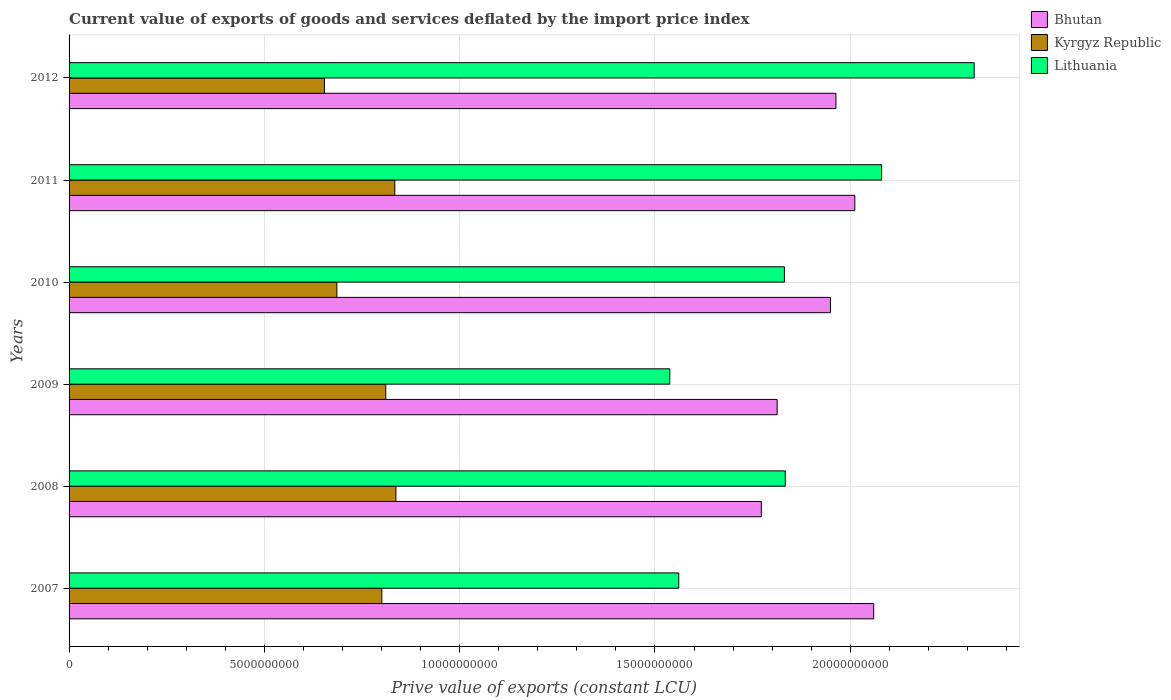Are the number of bars per tick equal to the number of legend labels?
Your answer should be very brief. Yes. Are the number of bars on each tick of the Y-axis equal?
Your answer should be very brief. Yes. How many bars are there on the 5th tick from the top?
Make the answer very short. 3. In how many cases, is the number of bars for a given year not equal to the number of legend labels?
Offer a terse response. 0. What is the prive value of exports in Lithuania in 2010?
Keep it short and to the point. 1.83e+1. Across all years, what is the maximum prive value of exports in Kyrgyz Republic?
Ensure brevity in your answer.  8.37e+09. Across all years, what is the minimum prive value of exports in Bhutan?
Your response must be concise. 1.77e+1. What is the total prive value of exports in Kyrgyz Republic in the graph?
Your answer should be compact. 4.62e+1. What is the difference between the prive value of exports in Bhutan in 2008 and that in 2011?
Your answer should be very brief. -2.39e+09. What is the difference between the prive value of exports in Bhutan in 2010 and the prive value of exports in Kyrgyz Republic in 2007?
Make the answer very short. 1.15e+1. What is the average prive value of exports in Kyrgyz Republic per year?
Offer a very short reply. 7.70e+09. In the year 2008, what is the difference between the prive value of exports in Bhutan and prive value of exports in Lithuania?
Ensure brevity in your answer.  -6.13e+08. What is the ratio of the prive value of exports in Lithuania in 2008 to that in 2011?
Your answer should be compact. 0.88. Is the prive value of exports in Kyrgyz Republic in 2008 less than that in 2009?
Ensure brevity in your answer.  No. What is the difference between the highest and the second highest prive value of exports in Kyrgyz Republic?
Offer a very short reply. 2.85e+07. What is the difference between the highest and the lowest prive value of exports in Kyrgyz Republic?
Provide a short and direct response. 1.83e+09. In how many years, is the prive value of exports in Lithuania greater than the average prive value of exports in Lithuania taken over all years?
Make the answer very short. 2. What does the 1st bar from the top in 2010 represents?
Keep it short and to the point. Lithuania. What does the 3rd bar from the bottom in 2009 represents?
Provide a short and direct response. Lithuania. Is it the case that in every year, the sum of the prive value of exports in Lithuania and prive value of exports in Kyrgyz Republic is greater than the prive value of exports in Bhutan?
Provide a succinct answer. Yes. Are all the bars in the graph horizontal?
Make the answer very short. Yes. How many years are there in the graph?
Make the answer very short. 6. What is the difference between two consecutive major ticks on the X-axis?
Provide a short and direct response. 5.00e+09. Does the graph contain grids?
Keep it short and to the point. Yes. How many legend labels are there?
Make the answer very short. 3. What is the title of the graph?
Your response must be concise. Current value of exports of goods and services deflated by the import price index. What is the label or title of the X-axis?
Offer a very short reply. Prive value of exports (constant LCU). What is the label or title of the Y-axis?
Offer a very short reply. Years. What is the Prive value of exports (constant LCU) in Bhutan in 2007?
Give a very brief answer. 2.06e+1. What is the Prive value of exports (constant LCU) of Kyrgyz Republic in 2007?
Make the answer very short. 8.01e+09. What is the Prive value of exports (constant LCU) in Lithuania in 2007?
Your answer should be compact. 1.56e+1. What is the Prive value of exports (constant LCU) in Bhutan in 2008?
Your answer should be very brief. 1.77e+1. What is the Prive value of exports (constant LCU) in Kyrgyz Republic in 2008?
Offer a terse response. 8.37e+09. What is the Prive value of exports (constant LCU) of Lithuania in 2008?
Provide a short and direct response. 1.83e+1. What is the Prive value of exports (constant LCU) of Bhutan in 2009?
Your answer should be compact. 1.81e+1. What is the Prive value of exports (constant LCU) in Kyrgyz Republic in 2009?
Your answer should be compact. 8.11e+09. What is the Prive value of exports (constant LCU) of Lithuania in 2009?
Make the answer very short. 1.54e+1. What is the Prive value of exports (constant LCU) in Bhutan in 2010?
Your answer should be very brief. 1.95e+1. What is the Prive value of exports (constant LCU) in Kyrgyz Republic in 2010?
Ensure brevity in your answer.  6.86e+09. What is the Prive value of exports (constant LCU) of Lithuania in 2010?
Your answer should be compact. 1.83e+1. What is the Prive value of exports (constant LCU) in Bhutan in 2011?
Your response must be concise. 2.01e+1. What is the Prive value of exports (constant LCU) in Kyrgyz Republic in 2011?
Offer a very short reply. 8.34e+09. What is the Prive value of exports (constant LCU) of Lithuania in 2011?
Make the answer very short. 2.08e+1. What is the Prive value of exports (constant LCU) in Bhutan in 2012?
Give a very brief answer. 1.96e+1. What is the Prive value of exports (constant LCU) of Kyrgyz Republic in 2012?
Ensure brevity in your answer.  6.54e+09. What is the Prive value of exports (constant LCU) of Lithuania in 2012?
Make the answer very short. 2.32e+1. Across all years, what is the maximum Prive value of exports (constant LCU) in Bhutan?
Provide a succinct answer. 2.06e+1. Across all years, what is the maximum Prive value of exports (constant LCU) of Kyrgyz Republic?
Provide a short and direct response. 8.37e+09. Across all years, what is the maximum Prive value of exports (constant LCU) in Lithuania?
Provide a succinct answer. 2.32e+1. Across all years, what is the minimum Prive value of exports (constant LCU) of Bhutan?
Provide a succinct answer. 1.77e+1. Across all years, what is the minimum Prive value of exports (constant LCU) in Kyrgyz Republic?
Your answer should be very brief. 6.54e+09. Across all years, what is the minimum Prive value of exports (constant LCU) in Lithuania?
Your response must be concise. 1.54e+1. What is the total Prive value of exports (constant LCU) in Bhutan in the graph?
Your answer should be very brief. 1.16e+11. What is the total Prive value of exports (constant LCU) in Kyrgyz Republic in the graph?
Offer a terse response. 4.62e+1. What is the total Prive value of exports (constant LCU) in Lithuania in the graph?
Provide a short and direct response. 1.12e+11. What is the difference between the Prive value of exports (constant LCU) in Bhutan in 2007 and that in 2008?
Provide a short and direct response. 2.88e+09. What is the difference between the Prive value of exports (constant LCU) of Kyrgyz Republic in 2007 and that in 2008?
Your answer should be compact. -3.60e+08. What is the difference between the Prive value of exports (constant LCU) of Lithuania in 2007 and that in 2008?
Keep it short and to the point. -2.73e+09. What is the difference between the Prive value of exports (constant LCU) of Bhutan in 2007 and that in 2009?
Offer a very short reply. 2.47e+09. What is the difference between the Prive value of exports (constant LCU) in Kyrgyz Republic in 2007 and that in 2009?
Your answer should be compact. -1.00e+08. What is the difference between the Prive value of exports (constant LCU) of Lithuania in 2007 and that in 2009?
Keep it short and to the point. 2.30e+08. What is the difference between the Prive value of exports (constant LCU) in Bhutan in 2007 and that in 2010?
Provide a succinct answer. 1.11e+09. What is the difference between the Prive value of exports (constant LCU) of Kyrgyz Republic in 2007 and that in 2010?
Offer a very short reply. 1.15e+09. What is the difference between the Prive value of exports (constant LCU) of Lithuania in 2007 and that in 2010?
Provide a succinct answer. -2.71e+09. What is the difference between the Prive value of exports (constant LCU) of Bhutan in 2007 and that in 2011?
Ensure brevity in your answer.  4.83e+08. What is the difference between the Prive value of exports (constant LCU) of Kyrgyz Republic in 2007 and that in 2011?
Your answer should be compact. -3.32e+08. What is the difference between the Prive value of exports (constant LCU) in Lithuania in 2007 and that in 2011?
Offer a very short reply. -5.19e+09. What is the difference between the Prive value of exports (constant LCU) in Bhutan in 2007 and that in 2012?
Offer a terse response. 9.67e+08. What is the difference between the Prive value of exports (constant LCU) in Kyrgyz Republic in 2007 and that in 2012?
Give a very brief answer. 1.47e+09. What is the difference between the Prive value of exports (constant LCU) of Lithuania in 2007 and that in 2012?
Make the answer very short. -7.56e+09. What is the difference between the Prive value of exports (constant LCU) in Bhutan in 2008 and that in 2009?
Offer a very short reply. -4.05e+08. What is the difference between the Prive value of exports (constant LCU) in Kyrgyz Republic in 2008 and that in 2009?
Provide a succinct answer. 2.60e+08. What is the difference between the Prive value of exports (constant LCU) in Lithuania in 2008 and that in 2009?
Keep it short and to the point. 2.96e+09. What is the difference between the Prive value of exports (constant LCU) of Bhutan in 2008 and that in 2010?
Your answer should be compact. -1.77e+09. What is the difference between the Prive value of exports (constant LCU) in Kyrgyz Republic in 2008 and that in 2010?
Keep it short and to the point. 1.51e+09. What is the difference between the Prive value of exports (constant LCU) in Lithuania in 2008 and that in 2010?
Provide a succinct answer. 2.17e+07. What is the difference between the Prive value of exports (constant LCU) in Bhutan in 2008 and that in 2011?
Provide a short and direct response. -2.39e+09. What is the difference between the Prive value of exports (constant LCU) in Kyrgyz Republic in 2008 and that in 2011?
Provide a succinct answer. 2.85e+07. What is the difference between the Prive value of exports (constant LCU) of Lithuania in 2008 and that in 2011?
Offer a very short reply. -2.47e+09. What is the difference between the Prive value of exports (constant LCU) in Bhutan in 2008 and that in 2012?
Your answer should be compact. -1.91e+09. What is the difference between the Prive value of exports (constant LCU) in Kyrgyz Republic in 2008 and that in 2012?
Offer a terse response. 1.83e+09. What is the difference between the Prive value of exports (constant LCU) in Lithuania in 2008 and that in 2012?
Your answer should be very brief. -4.84e+09. What is the difference between the Prive value of exports (constant LCU) of Bhutan in 2009 and that in 2010?
Offer a terse response. -1.36e+09. What is the difference between the Prive value of exports (constant LCU) in Kyrgyz Republic in 2009 and that in 2010?
Offer a very short reply. 1.25e+09. What is the difference between the Prive value of exports (constant LCU) of Lithuania in 2009 and that in 2010?
Your answer should be very brief. -2.94e+09. What is the difference between the Prive value of exports (constant LCU) in Bhutan in 2009 and that in 2011?
Provide a short and direct response. -1.99e+09. What is the difference between the Prive value of exports (constant LCU) in Kyrgyz Republic in 2009 and that in 2011?
Give a very brief answer. -2.32e+08. What is the difference between the Prive value of exports (constant LCU) of Lithuania in 2009 and that in 2011?
Your answer should be very brief. -5.42e+09. What is the difference between the Prive value of exports (constant LCU) in Bhutan in 2009 and that in 2012?
Provide a short and direct response. -1.50e+09. What is the difference between the Prive value of exports (constant LCU) of Kyrgyz Republic in 2009 and that in 2012?
Offer a terse response. 1.57e+09. What is the difference between the Prive value of exports (constant LCU) of Lithuania in 2009 and that in 2012?
Provide a succinct answer. -7.79e+09. What is the difference between the Prive value of exports (constant LCU) in Bhutan in 2010 and that in 2011?
Keep it short and to the point. -6.25e+08. What is the difference between the Prive value of exports (constant LCU) in Kyrgyz Republic in 2010 and that in 2011?
Offer a very short reply. -1.48e+09. What is the difference between the Prive value of exports (constant LCU) in Lithuania in 2010 and that in 2011?
Give a very brief answer. -2.49e+09. What is the difference between the Prive value of exports (constant LCU) in Bhutan in 2010 and that in 2012?
Give a very brief answer. -1.41e+08. What is the difference between the Prive value of exports (constant LCU) of Kyrgyz Republic in 2010 and that in 2012?
Ensure brevity in your answer.  3.18e+08. What is the difference between the Prive value of exports (constant LCU) in Lithuania in 2010 and that in 2012?
Ensure brevity in your answer.  -4.86e+09. What is the difference between the Prive value of exports (constant LCU) of Bhutan in 2011 and that in 2012?
Provide a succinct answer. 4.83e+08. What is the difference between the Prive value of exports (constant LCU) in Kyrgyz Republic in 2011 and that in 2012?
Ensure brevity in your answer.  1.80e+09. What is the difference between the Prive value of exports (constant LCU) in Lithuania in 2011 and that in 2012?
Provide a short and direct response. -2.37e+09. What is the difference between the Prive value of exports (constant LCU) in Bhutan in 2007 and the Prive value of exports (constant LCU) in Kyrgyz Republic in 2008?
Your answer should be compact. 1.22e+1. What is the difference between the Prive value of exports (constant LCU) in Bhutan in 2007 and the Prive value of exports (constant LCU) in Lithuania in 2008?
Offer a very short reply. 2.26e+09. What is the difference between the Prive value of exports (constant LCU) in Kyrgyz Republic in 2007 and the Prive value of exports (constant LCU) in Lithuania in 2008?
Provide a short and direct response. -1.03e+1. What is the difference between the Prive value of exports (constant LCU) in Bhutan in 2007 and the Prive value of exports (constant LCU) in Kyrgyz Republic in 2009?
Your answer should be very brief. 1.25e+1. What is the difference between the Prive value of exports (constant LCU) in Bhutan in 2007 and the Prive value of exports (constant LCU) in Lithuania in 2009?
Your response must be concise. 5.22e+09. What is the difference between the Prive value of exports (constant LCU) in Kyrgyz Republic in 2007 and the Prive value of exports (constant LCU) in Lithuania in 2009?
Provide a short and direct response. -7.37e+09. What is the difference between the Prive value of exports (constant LCU) of Bhutan in 2007 and the Prive value of exports (constant LCU) of Kyrgyz Republic in 2010?
Your response must be concise. 1.37e+1. What is the difference between the Prive value of exports (constant LCU) in Bhutan in 2007 and the Prive value of exports (constant LCU) in Lithuania in 2010?
Offer a terse response. 2.29e+09. What is the difference between the Prive value of exports (constant LCU) of Kyrgyz Republic in 2007 and the Prive value of exports (constant LCU) of Lithuania in 2010?
Offer a very short reply. -1.03e+1. What is the difference between the Prive value of exports (constant LCU) in Bhutan in 2007 and the Prive value of exports (constant LCU) in Kyrgyz Republic in 2011?
Your answer should be compact. 1.23e+1. What is the difference between the Prive value of exports (constant LCU) of Bhutan in 2007 and the Prive value of exports (constant LCU) of Lithuania in 2011?
Provide a short and direct response. -2.03e+08. What is the difference between the Prive value of exports (constant LCU) in Kyrgyz Republic in 2007 and the Prive value of exports (constant LCU) in Lithuania in 2011?
Offer a very short reply. -1.28e+1. What is the difference between the Prive value of exports (constant LCU) of Bhutan in 2007 and the Prive value of exports (constant LCU) of Kyrgyz Republic in 2012?
Your answer should be compact. 1.41e+1. What is the difference between the Prive value of exports (constant LCU) of Bhutan in 2007 and the Prive value of exports (constant LCU) of Lithuania in 2012?
Make the answer very short. -2.57e+09. What is the difference between the Prive value of exports (constant LCU) of Kyrgyz Republic in 2007 and the Prive value of exports (constant LCU) of Lithuania in 2012?
Your answer should be compact. -1.52e+1. What is the difference between the Prive value of exports (constant LCU) of Bhutan in 2008 and the Prive value of exports (constant LCU) of Kyrgyz Republic in 2009?
Provide a succinct answer. 9.62e+09. What is the difference between the Prive value of exports (constant LCU) in Bhutan in 2008 and the Prive value of exports (constant LCU) in Lithuania in 2009?
Make the answer very short. 2.34e+09. What is the difference between the Prive value of exports (constant LCU) of Kyrgyz Republic in 2008 and the Prive value of exports (constant LCU) of Lithuania in 2009?
Make the answer very short. -7.01e+09. What is the difference between the Prive value of exports (constant LCU) in Bhutan in 2008 and the Prive value of exports (constant LCU) in Kyrgyz Republic in 2010?
Your answer should be very brief. 1.09e+1. What is the difference between the Prive value of exports (constant LCU) of Bhutan in 2008 and the Prive value of exports (constant LCU) of Lithuania in 2010?
Keep it short and to the point. -5.91e+08. What is the difference between the Prive value of exports (constant LCU) of Kyrgyz Republic in 2008 and the Prive value of exports (constant LCU) of Lithuania in 2010?
Give a very brief answer. -9.95e+09. What is the difference between the Prive value of exports (constant LCU) of Bhutan in 2008 and the Prive value of exports (constant LCU) of Kyrgyz Republic in 2011?
Keep it short and to the point. 9.38e+09. What is the difference between the Prive value of exports (constant LCU) in Bhutan in 2008 and the Prive value of exports (constant LCU) in Lithuania in 2011?
Offer a terse response. -3.08e+09. What is the difference between the Prive value of exports (constant LCU) of Kyrgyz Republic in 2008 and the Prive value of exports (constant LCU) of Lithuania in 2011?
Provide a short and direct response. -1.24e+1. What is the difference between the Prive value of exports (constant LCU) of Bhutan in 2008 and the Prive value of exports (constant LCU) of Kyrgyz Republic in 2012?
Provide a succinct answer. 1.12e+1. What is the difference between the Prive value of exports (constant LCU) of Bhutan in 2008 and the Prive value of exports (constant LCU) of Lithuania in 2012?
Ensure brevity in your answer.  -5.45e+09. What is the difference between the Prive value of exports (constant LCU) of Kyrgyz Republic in 2008 and the Prive value of exports (constant LCU) of Lithuania in 2012?
Your answer should be compact. -1.48e+1. What is the difference between the Prive value of exports (constant LCU) in Bhutan in 2009 and the Prive value of exports (constant LCU) in Kyrgyz Republic in 2010?
Provide a succinct answer. 1.13e+1. What is the difference between the Prive value of exports (constant LCU) in Bhutan in 2009 and the Prive value of exports (constant LCU) in Lithuania in 2010?
Provide a short and direct response. -1.86e+08. What is the difference between the Prive value of exports (constant LCU) of Kyrgyz Republic in 2009 and the Prive value of exports (constant LCU) of Lithuania in 2010?
Your answer should be very brief. -1.02e+1. What is the difference between the Prive value of exports (constant LCU) in Bhutan in 2009 and the Prive value of exports (constant LCU) in Kyrgyz Republic in 2011?
Provide a succinct answer. 9.79e+09. What is the difference between the Prive value of exports (constant LCU) in Bhutan in 2009 and the Prive value of exports (constant LCU) in Lithuania in 2011?
Offer a very short reply. -2.67e+09. What is the difference between the Prive value of exports (constant LCU) in Kyrgyz Republic in 2009 and the Prive value of exports (constant LCU) in Lithuania in 2011?
Your answer should be compact. -1.27e+1. What is the difference between the Prive value of exports (constant LCU) in Bhutan in 2009 and the Prive value of exports (constant LCU) in Kyrgyz Republic in 2012?
Offer a terse response. 1.16e+1. What is the difference between the Prive value of exports (constant LCU) in Bhutan in 2009 and the Prive value of exports (constant LCU) in Lithuania in 2012?
Give a very brief answer. -5.04e+09. What is the difference between the Prive value of exports (constant LCU) of Kyrgyz Republic in 2009 and the Prive value of exports (constant LCU) of Lithuania in 2012?
Offer a very short reply. -1.51e+1. What is the difference between the Prive value of exports (constant LCU) of Bhutan in 2010 and the Prive value of exports (constant LCU) of Kyrgyz Republic in 2011?
Ensure brevity in your answer.  1.12e+1. What is the difference between the Prive value of exports (constant LCU) of Bhutan in 2010 and the Prive value of exports (constant LCU) of Lithuania in 2011?
Give a very brief answer. -1.31e+09. What is the difference between the Prive value of exports (constant LCU) of Kyrgyz Republic in 2010 and the Prive value of exports (constant LCU) of Lithuania in 2011?
Give a very brief answer. -1.39e+1. What is the difference between the Prive value of exports (constant LCU) in Bhutan in 2010 and the Prive value of exports (constant LCU) in Kyrgyz Republic in 2012?
Offer a very short reply. 1.30e+1. What is the difference between the Prive value of exports (constant LCU) in Bhutan in 2010 and the Prive value of exports (constant LCU) in Lithuania in 2012?
Offer a very short reply. -3.68e+09. What is the difference between the Prive value of exports (constant LCU) in Kyrgyz Republic in 2010 and the Prive value of exports (constant LCU) in Lithuania in 2012?
Give a very brief answer. -1.63e+1. What is the difference between the Prive value of exports (constant LCU) of Bhutan in 2011 and the Prive value of exports (constant LCU) of Kyrgyz Republic in 2012?
Provide a succinct answer. 1.36e+1. What is the difference between the Prive value of exports (constant LCU) in Bhutan in 2011 and the Prive value of exports (constant LCU) in Lithuania in 2012?
Make the answer very short. -3.06e+09. What is the difference between the Prive value of exports (constant LCU) of Kyrgyz Republic in 2011 and the Prive value of exports (constant LCU) of Lithuania in 2012?
Provide a short and direct response. -1.48e+1. What is the average Prive value of exports (constant LCU) in Bhutan per year?
Keep it short and to the point. 1.93e+1. What is the average Prive value of exports (constant LCU) in Kyrgyz Republic per year?
Provide a short and direct response. 7.70e+09. What is the average Prive value of exports (constant LCU) in Lithuania per year?
Offer a very short reply. 1.86e+1. In the year 2007, what is the difference between the Prive value of exports (constant LCU) of Bhutan and Prive value of exports (constant LCU) of Kyrgyz Republic?
Offer a terse response. 1.26e+1. In the year 2007, what is the difference between the Prive value of exports (constant LCU) in Bhutan and Prive value of exports (constant LCU) in Lithuania?
Give a very brief answer. 4.99e+09. In the year 2007, what is the difference between the Prive value of exports (constant LCU) of Kyrgyz Republic and Prive value of exports (constant LCU) of Lithuania?
Your response must be concise. -7.60e+09. In the year 2008, what is the difference between the Prive value of exports (constant LCU) in Bhutan and Prive value of exports (constant LCU) in Kyrgyz Republic?
Your answer should be very brief. 9.36e+09. In the year 2008, what is the difference between the Prive value of exports (constant LCU) of Bhutan and Prive value of exports (constant LCU) of Lithuania?
Your answer should be very brief. -6.13e+08. In the year 2008, what is the difference between the Prive value of exports (constant LCU) in Kyrgyz Republic and Prive value of exports (constant LCU) in Lithuania?
Give a very brief answer. -9.97e+09. In the year 2009, what is the difference between the Prive value of exports (constant LCU) of Bhutan and Prive value of exports (constant LCU) of Kyrgyz Republic?
Provide a succinct answer. 1.00e+1. In the year 2009, what is the difference between the Prive value of exports (constant LCU) in Bhutan and Prive value of exports (constant LCU) in Lithuania?
Provide a succinct answer. 2.75e+09. In the year 2009, what is the difference between the Prive value of exports (constant LCU) of Kyrgyz Republic and Prive value of exports (constant LCU) of Lithuania?
Offer a terse response. -7.27e+09. In the year 2010, what is the difference between the Prive value of exports (constant LCU) of Bhutan and Prive value of exports (constant LCU) of Kyrgyz Republic?
Provide a succinct answer. 1.26e+1. In the year 2010, what is the difference between the Prive value of exports (constant LCU) of Bhutan and Prive value of exports (constant LCU) of Lithuania?
Offer a very short reply. 1.18e+09. In the year 2010, what is the difference between the Prive value of exports (constant LCU) of Kyrgyz Republic and Prive value of exports (constant LCU) of Lithuania?
Provide a short and direct response. -1.15e+1. In the year 2011, what is the difference between the Prive value of exports (constant LCU) of Bhutan and Prive value of exports (constant LCU) of Kyrgyz Republic?
Offer a terse response. 1.18e+1. In the year 2011, what is the difference between the Prive value of exports (constant LCU) of Bhutan and Prive value of exports (constant LCU) of Lithuania?
Provide a succinct answer. -6.87e+08. In the year 2011, what is the difference between the Prive value of exports (constant LCU) of Kyrgyz Republic and Prive value of exports (constant LCU) of Lithuania?
Your response must be concise. -1.25e+1. In the year 2012, what is the difference between the Prive value of exports (constant LCU) of Bhutan and Prive value of exports (constant LCU) of Kyrgyz Republic?
Offer a very short reply. 1.31e+1. In the year 2012, what is the difference between the Prive value of exports (constant LCU) in Bhutan and Prive value of exports (constant LCU) in Lithuania?
Make the answer very short. -3.54e+09. In the year 2012, what is the difference between the Prive value of exports (constant LCU) of Kyrgyz Republic and Prive value of exports (constant LCU) of Lithuania?
Keep it short and to the point. -1.66e+1. What is the ratio of the Prive value of exports (constant LCU) of Bhutan in 2007 to that in 2008?
Provide a short and direct response. 1.16. What is the ratio of the Prive value of exports (constant LCU) of Lithuania in 2007 to that in 2008?
Give a very brief answer. 0.85. What is the ratio of the Prive value of exports (constant LCU) of Bhutan in 2007 to that in 2009?
Offer a very short reply. 1.14. What is the ratio of the Prive value of exports (constant LCU) of Lithuania in 2007 to that in 2009?
Your answer should be compact. 1.01. What is the ratio of the Prive value of exports (constant LCU) in Bhutan in 2007 to that in 2010?
Keep it short and to the point. 1.06. What is the ratio of the Prive value of exports (constant LCU) of Kyrgyz Republic in 2007 to that in 2010?
Offer a terse response. 1.17. What is the ratio of the Prive value of exports (constant LCU) in Lithuania in 2007 to that in 2010?
Provide a succinct answer. 0.85. What is the ratio of the Prive value of exports (constant LCU) in Kyrgyz Republic in 2007 to that in 2011?
Offer a very short reply. 0.96. What is the ratio of the Prive value of exports (constant LCU) of Lithuania in 2007 to that in 2011?
Give a very brief answer. 0.75. What is the ratio of the Prive value of exports (constant LCU) of Bhutan in 2007 to that in 2012?
Give a very brief answer. 1.05. What is the ratio of the Prive value of exports (constant LCU) in Kyrgyz Republic in 2007 to that in 2012?
Provide a succinct answer. 1.22. What is the ratio of the Prive value of exports (constant LCU) of Lithuania in 2007 to that in 2012?
Your answer should be very brief. 0.67. What is the ratio of the Prive value of exports (constant LCU) in Bhutan in 2008 to that in 2009?
Offer a very short reply. 0.98. What is the ratio of the Prive value of exports (constant LCU) of Kyrgyz Republic in 2008 to that in 2009?
Offer a terse response. 1.03. What is the ratio of the Prive value of exports (constant LCU) in Lithuania in 2008 to that in 2009?
Make the answer very short. 1.19. What is the ratio of the Prive value of exports (constant LCU) of Bhutan in 2008 to that in 2010?
Your response must be concise. 0.91. What is the ratio of the Prive value of exports (constant LCU) in Kyrgyz Republic in 2008 to that in 2010?
Make the answer very short. 1.22. What is the ratio of the Prive value of exports (constant LCU) of Bhutan in 2008 to that in 2011?
Provide a succinct answer. 0.88. What is the ratio of the Prive value of exports (constant LCU) of Kyrgyz Republic in 2008 to that in 2011?
Your answer should be compact. 1. What is the ratio of the Prive value of exports (constant LCU) of Lithuania in 2008 to that in 2011?
Provide a succinct answer. 0.88. What is the ratio of the Prive value of exports (constant LCU) of Bhutan in 2008 to that in 2012?
Keep it short and to the point. 0.9. What is the ratio of the Prive value of exports (constant LCU) of Kyrgyz Republic in 2008 to that in 2012?
Offer a terse response. 1.28. What is the ratio of the Prive value of exports (constant LCU) of Lithuania in 2008 to that in 2012?
Your response must be concise. 0.79. What is the ratio of the Prive value of exports (constant LCU) of Bhutan in 2009 to that in 2010?
Your response must be concise. 0.93. What is the ratio of the Prive value of exports (constant LCU) of Kyrgyz Republic in 2009 to that in 2010?
Offer a very short reply. 1.18. What is the ratio of the Prive value of exports (constant LCU) of Lithuania in 2009 to that in 2010?
Give a very brief answer. 0.84. What is the ratio of the Prive value of exports (constant LCU) in Bhutan in 2009 to that in 2011?
Provide a short and direct response. 0.9. What is the ratio of the Prive value of exports (constant LCU) in Kyrgyz Republic in 2009 to that in 2011?
Offer a terse response. 0.97. What is the ratio of the Prive value of exports (constant LCU) in Lithuania in 2009 to that in 2011?
Keep it short and to the point. 0.74. What is the ratio of the Prive value of exports (constant LCU) in Bhutan in 2009 to that in 2012?
Your answer should be compact. 0.92. What is the ratio of the Prive value of exports (constant LCU) in Kyrgyz Republic in 2009 to that in 2012?
Offer a terse response. 1.24. What is the ratio of the Prive value of exports (constant LCU) in Lithuania in 2009 to that in 2012?
Offer a very short reply. 0.66. What is the ratio of the Prive value of exports (constant LCU) in Bhutan in 2010 to that in 2011?
Provide a short and direct response. 0.97. What is the ratio of the Prive value of exports (constant LCU) of Kyrgyz Republic in 2010 to that in 2011?
Provide a succinct answer. 0.82. What is the ratio of the Prive value of exports (constant LCU) in Lithuania in 2010 to that in 2011?
Your response must be concise. 0.88. What is the ratio of the Prive value of exports (constant LCU) of Bhutan in 2010 to that in 2012?
Keep it short and to the point. 0.99. What is the ratio of the Prive value of exports (constant LCU) in Kyrgyz Republic in 2010 to that in 2012?
Ensure brevity in your answer.  1.05. What is the ratio of the Prive value of exports (constant LCU) in Lithuania in 2010 to that in 2012?
Provide a succinct answer. 0.79. What is the ratio of the Prive value of exports (constant LCU) of Bhutan in 2011 to that in 2012?
Your response must be concise. 1.02. What is the ratio of the Prive value of exports (constant LCU) of Kyrgyz Republic in 2011 to that in 2012?
Provide a succinct answer. 1.28. What is the ratio of the Prive value of exports (constant LCU) in Lithuania in 2011 to that in 2012?
Offer a very short reply. 0.9. What is the difference between the highest and the second highest Prive value of exports (constant LCU) in Bhutan?
Offer a very short reply. 4.83e+08. What is the difference between the highest and the second highest Prive value of exports (constant LCU) in Kyrgyz Republic?
Your answer should be very brief. 2.85e+07. What is the difference between the highest and the second highest Prive value of exports (constant LCU) in Lithuania?
Give a very brief answer. 2.37e+09. What is the difference between the highest and the lowest Prive value of exports (constant LCU) of Bhutan?
Provide a short and direct response. 2.88e+09. What is the difference between the highest and the lowest Prive value of exports (constant LCU) of Kyrgyz Republic?
Offer a terse response. 1.83e+09. What is the difference between the highest and the lowest Prive value of exports (constant LCU) in Lithuania?
Provide a short and direct response. 7.79e+09. 